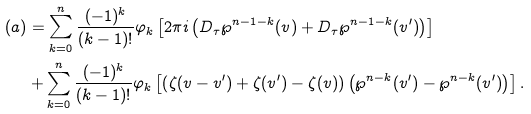Convert formula to latex. <formula><loc_0><loc_0><loc_500><loc_500>( a ) & = \sum _ { k = 0 } ^ { n } \frac { ( - 1 ) ^ { k } } { ( k - 1 ) ! } \varphi _ { k } \left [ 2 \pi i \left ( D _ { \tau } \wp ^ { n - 1 - k } ( v ) + D _ { \tau } \wp ^ { n - 1 - k } ( v ^ { \prime } ) \right ) \right ] \\ & + \sum _ { k = 0 } ^ { n } \frac { ( - 1 ) ^ { k } } { ( k - 1 ) ! } \varphi _ { k } \left [ \left ( \zeta ( v - v ^ { \prime } ) + \zeta ( v ^ { \prime } ) - \zeta ( v ) \right ) \left ( \wp ^ { n - k } ( v ^ { \prime } ) - \wp ^ { n - k } ( v ^ { \prime } ) \right ) \right ] .</formula> 